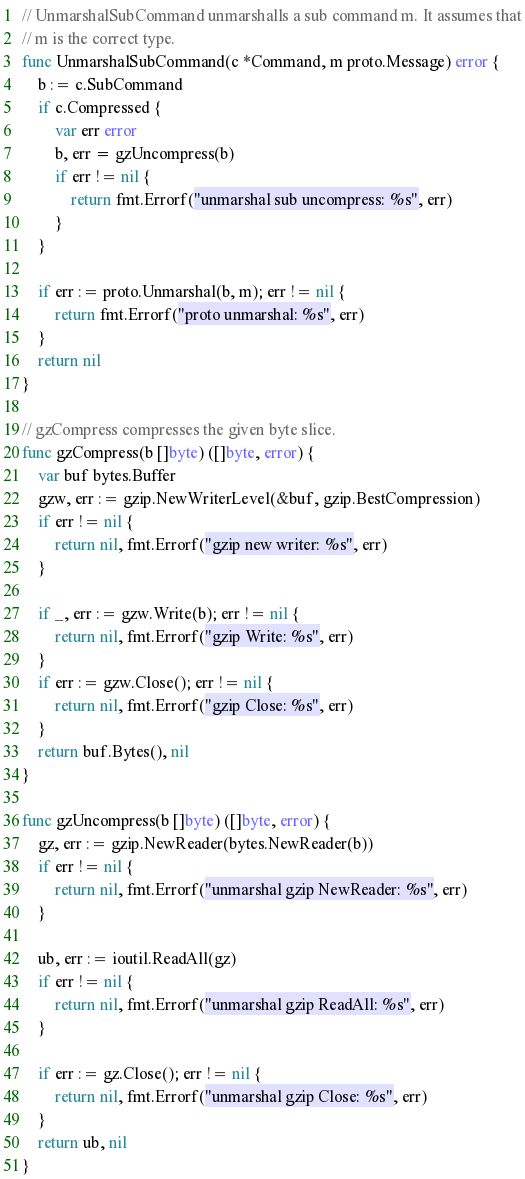<code> <loc_0><loc_0><loc_500><loc_500><_Go_>
// UnmarshalSubCommand unmarshalls a sub command m. It assumes that
// m is the correct type.
func UnmarshalSubCommand(c *Command, m proto.Message) error {
	b := c.SubCommand
	if c.Compressed {
		var err error
		b, err = gzUncompress(b)
		if err != nil {
			return fmt.Errorf("unmarshal sub uncompress: %s", err)
		}
	}

	if err := proto.Unmarshal(b, m); err != nil {
		return fmt.Errorf("proto unmarshal: %s", err)
	}
	return nil
}

// gzCompress compresses the given byte slice.
func gzCompress(b []byte) ([]byte, error) {
	var buf bytes.Buffer
	gzw, err := gzip.NewWriterLevel(&buf, gzip.BestCompression)
	if err != nil {
		return nil, fmt.Errorf("gzip new writer: %s", err)
	}

	if _, err := gzw.Write(b); err != nil {
		return nil, fmt.Errorf("gzip Write: %s", err)
	}
	if err := gzw.Close(); err != nil {
		return nil, fmt.Errorf("gzip Close: %s", err)
	}
	return buf.Bytes(), nil
}

func gzUncompress(b []byte) ([]byte, error) {
	gz, err := gzip.NewReader(bytes.NewReader(b))
	if err != nil {
		return nil, fmt.Errorf("unmarshal gzip NewReader: %s", err)
	}

	ub, err := ioutil.ReadAll(gz)
	if err != nil {
		return nil, fmt.Errorf("unmarshal gzip ReadAll: %s", err)
	}

	if err := gz.Close(); err != nil {
		return nil, fmt.Errorf("unmarshal gzip Close: %s", err)
	}
	return ub, nil
}
</code> 